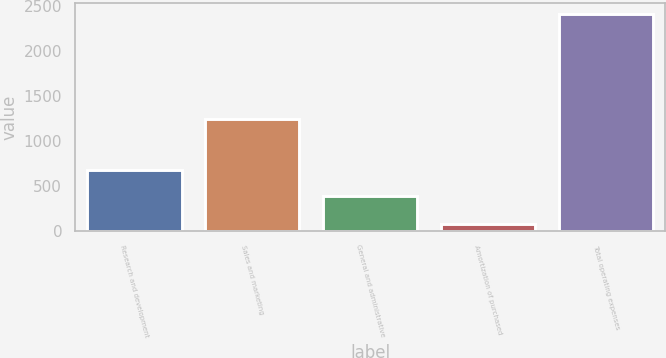Convert chart. <chart><loc_0><loc_0><loc_500><loc_500><bar_chart><fcel>Research and development<fcel>Sales and marketing<fcel>General and administrative<fcel>Amortization of purchased<fcel>Total operating expenses<nl><fcel>680.3<fcel>1244.2<fcel>383.5<fcel>72.1<fcel>2403.4<nl></chart> 